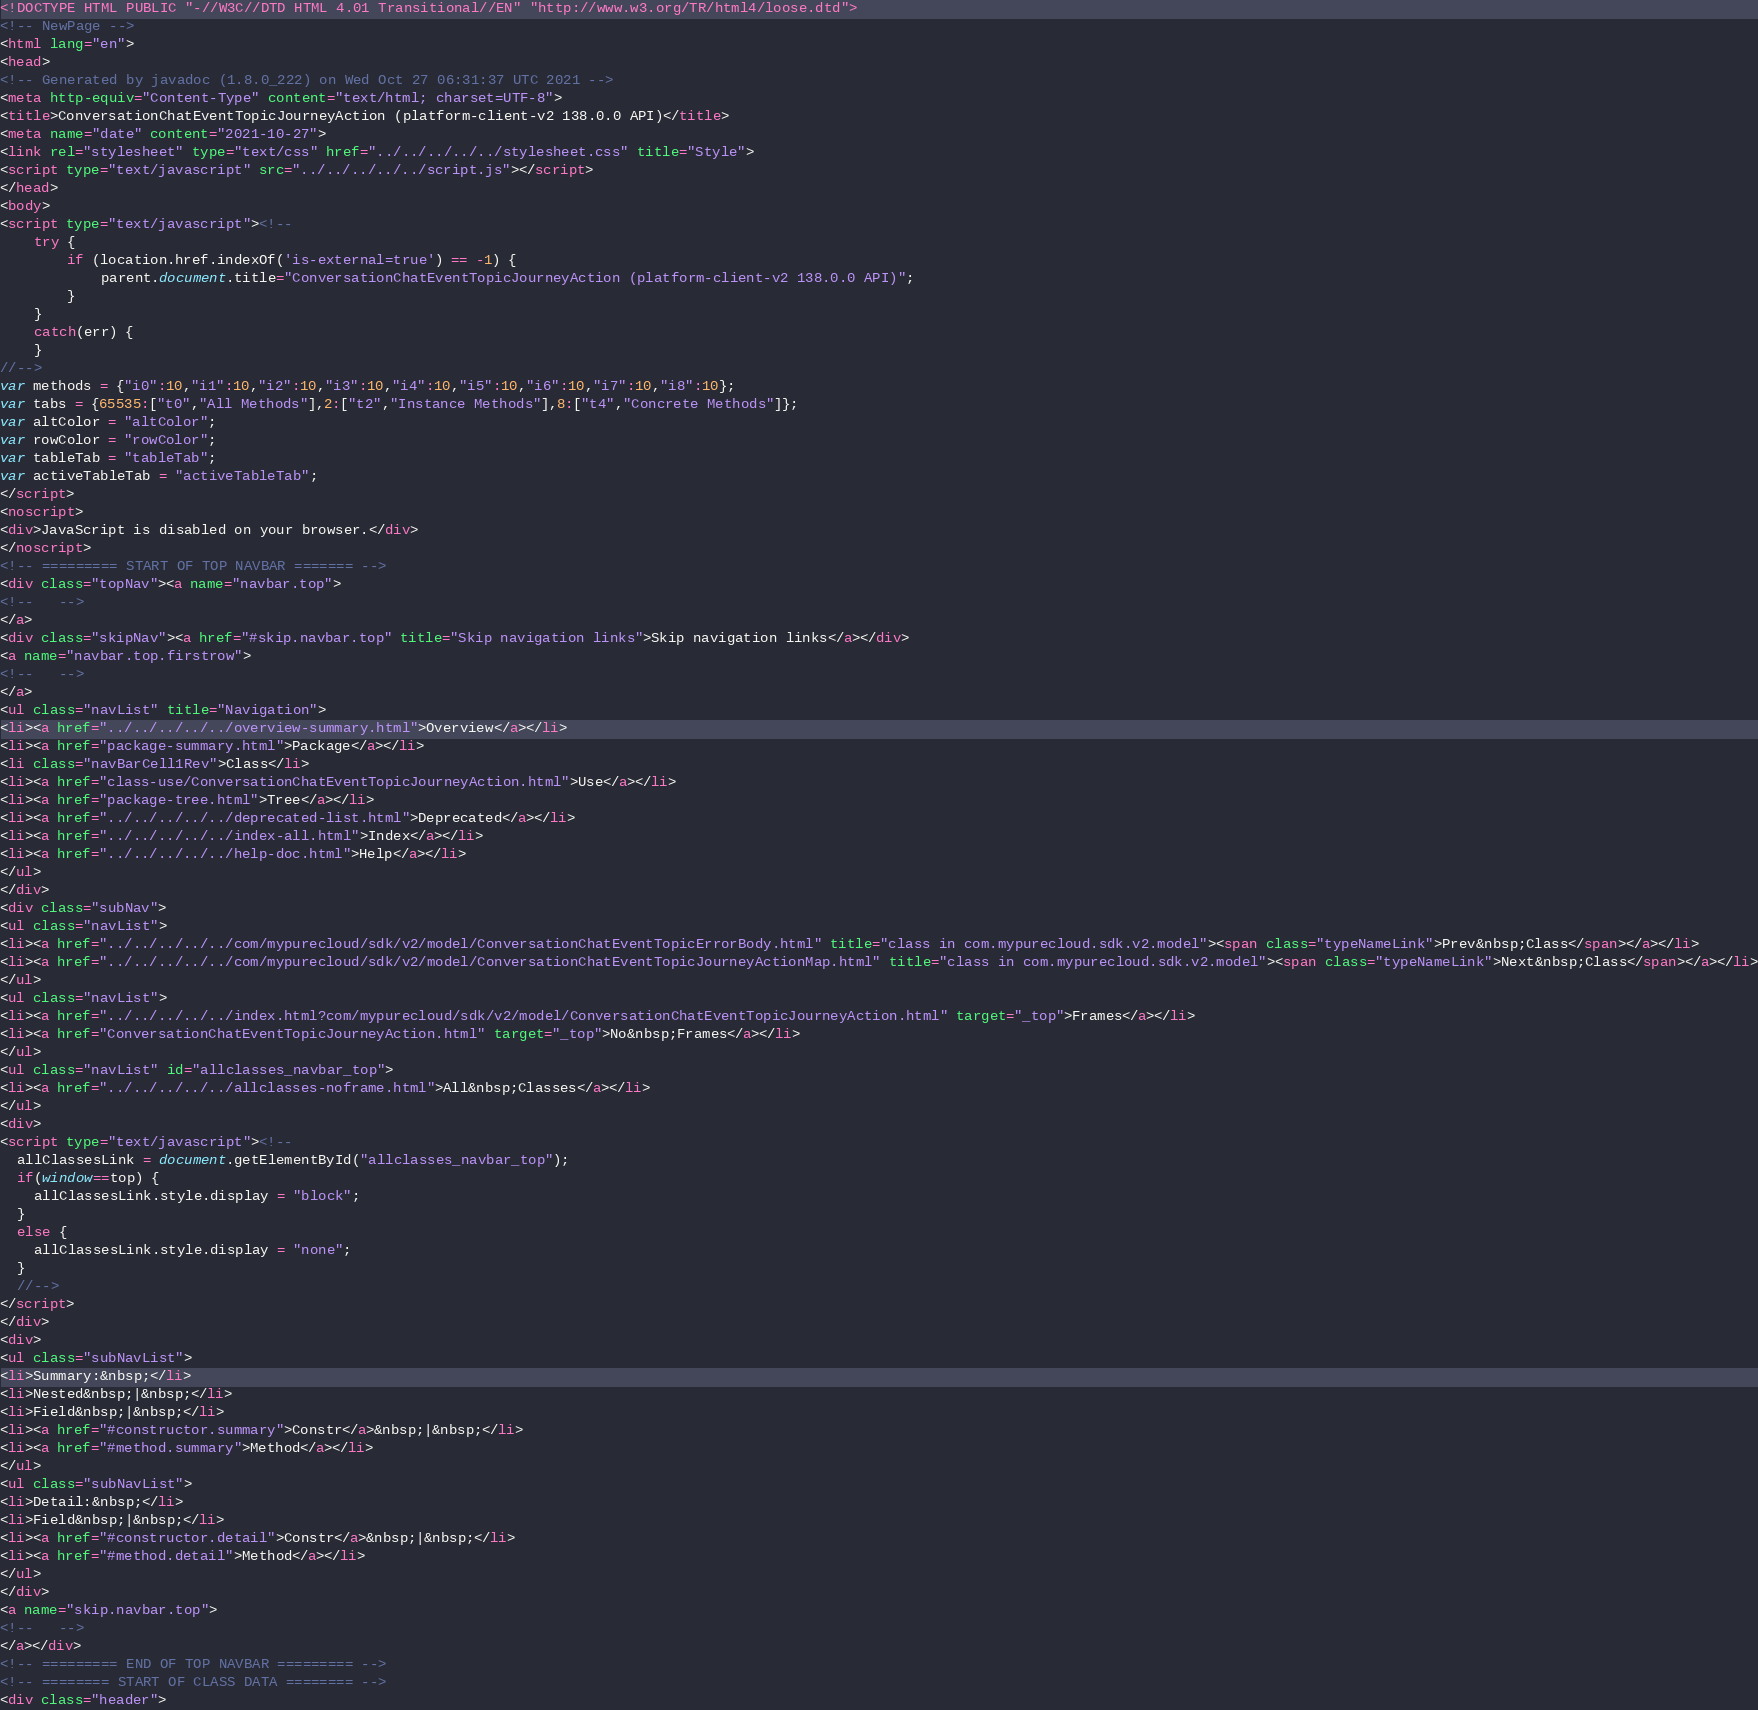<code> <loc_0><loc_0><loc_500><loc_500><_HTML_><!DOCTYPE HTML PUBLIC "-//W3C//DTD HTML 4.01 Transitional//EN" "http://www.w3.org/TR/html4/loose.dtd">
<!-- NewPage -->
<html lang="en">
<head>
<!-- Generated by javadoc (1.8.0_222) on Wed Oct 27 06:31:37 UTC 2021 -->
<meta http-equiv="Content-Type" content="text/html; charset=UTF-8">
<title>ConversationChatEventTopicJourneyAction (platform-client-v2 138.0.0 API)</title>
<meta name="date" content="2021-10-27">
<link rel="stylesheet" type="text/css" href="../../../../../stylesheet.css" title="Style">
<script type="text/javascript" src="../../../../../script.js"></script>
</head>
<body>
<script type="text/javascript"><!--
    try {
        if (location.href.indexOf('is-external=true') == -1) {
            parent.document.title="ConversationChatEventTopicJourneyAction (platform-client-v2 138.0.0 API)";
        }
    }
    catch(err) {
    }
//-->
var methods = {"i0":10,"i1":10,"i2":10,"i3":10,"i4":10,"i5":10,"i6":10,"i7":10,"i8":10};
var tabs = {65535:["t0","All Methods"],2:["t2","Instance Methods"],8:["t4","Concrete Methods"]};
var altColor = "altColor";
var rowColor = "rowColor";
var tableTab = "tableTab";
var activeTableTab = "activeTableTab";
</script>
<noscript>
<div>JavaScript is disabled on your browser.</div>
</noscript>
<!-- ========= START OF TOP NAVBAR ======= -->
<div class="topNav"><a name="navbar.top">
<!--   -->
</a>
<div class="skipNav"><a href="#skip.navbar.top" title="Skip navigation links">Skip navigation links</a></div>
<a name="navbar.top.firstrow">
<!--   -->
</a>
<ul class="navList" title="Navigation">
<li><a href="../../../../../overview-summary.html">Overview</a></li>
<li><a href="package-summary.html">Package</a></li>
<li class="navBarCell1Rev">Class</li>
<li><a href="class-use/ConversationChatEventTopicJourneyAction.html">Use</a></li>
<li><a href="package-tree.html">Tree</a></li>
<li><a href="../../../../../deprecated-list.html">Deprecated</a></li>
<li><a href="../../../../../index-all.html">Index</a></li>
<li><a href="../../../../../help-doc.html">Help</a></li>
</ul>
</div>
<div class="subNav">
<ul class="navList">
<li><a href="../../../../../com/mypurecloud/sdk/v2/model/ConversationChatEventTopicErrorBody.html" title="class in com.mypurecloud.sdk.v2.model"><span class="typeNameLink">Prev&nbsp;Class</span></a></li>
<li><a href="../../../../../com/mypurecloud/sdk/v2/model/ConversationChatEventTopicJourneyActionMap.html" title="class in com.mypurecloud.sdk.v2.model"><span class="typeNameLink">Next&nbsp;Class</span></a></li>
</ul>
<ul class="navList">
<li><a href="../../../../../index.html?com/mypurecloud/sdk/v2/model/ConversationChatEventTopicJourneyAction.html" target="_top">Frames</a></li>
<li><a href="ConversationChatEventTopicJourneyAction.html" target="_top">No&nbsp;Frames</a></li>
</ul>
<ul class="navList" id="allclasses_navbar_top">
<li><a href="../../../../../allclasses-noframe.html">All&nbsp;Classes</a></li>
</ul>
<div>
<script type="text/javascript"><!--
  allClassesLink = document.getElementById("allclasses_navbar_top");
  if(window==top) {
    allClassesLink.style.display = "block";
  }
  else {
    allClassesLink.style.display = "none";
  }
  //-->
</script>
</div>
<div>
<ul class="subNavList">
<li>Summary:&nbsp;</li>
<li>Nested&nbsp;|&nbsp;</li>
<li>Field&nbsp;|&nbsp;</li>
<li><a href="#constructor.summary">Constr</a>&nbsp;|&nbsp;</li>
<li><a href="#method.summary">Method</a></li>
</ul>
<ul class="subNavList">
<li>Detail:&nbsp;</li>
<li>Field&nbsp;|&nbsp;</li>
<li><a href="#constructor.detail">Constr</a>&nbsp;|&nbsp;</li>
<li><a href="#method.detail">Method</a></li>
</ul>
</div>
<a name="skip.navbar.top">
<!--   -->
</a></div>
<!-- ========= END OF TOP NAVBAR ========= -->
<!-- ======== START OF CLASS DATA ======== -->
<div class="header"></code> 